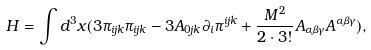<formula> <loc_0><loc_0><loc_500><loc_500>H = \int d ^ { 3 } x ( 3 \pi _ { i j k } \pi _ { i j k } - 3 A _ { 0 j k } \partial _ { i } \pi ^ { i j k } + \frac { M ^ { 2 } } { 2 \cdot 3 ! } A _ { \alpha \beta \gamma } A ^ { \alpha \beta \gamma } ) ,</formula> 